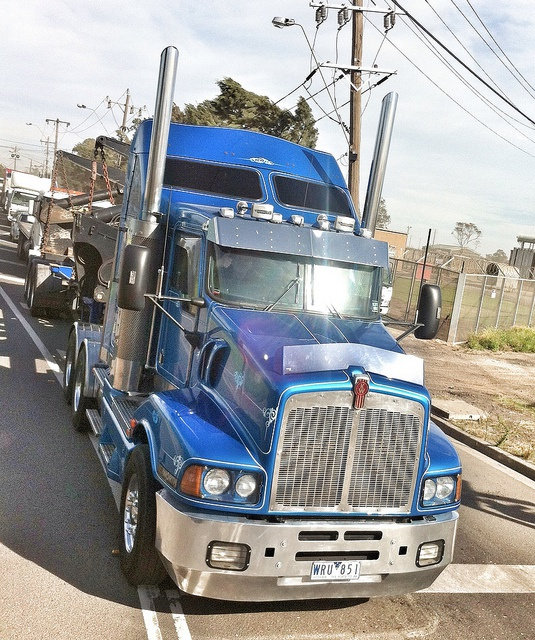Describe the objects in this image and their specific colors. I can see truck in white, gray, darkgray, black, and lightgray tones, truck in white, gray, and darkgray tones, and people in white, gray, and darkgray tones in this image. 